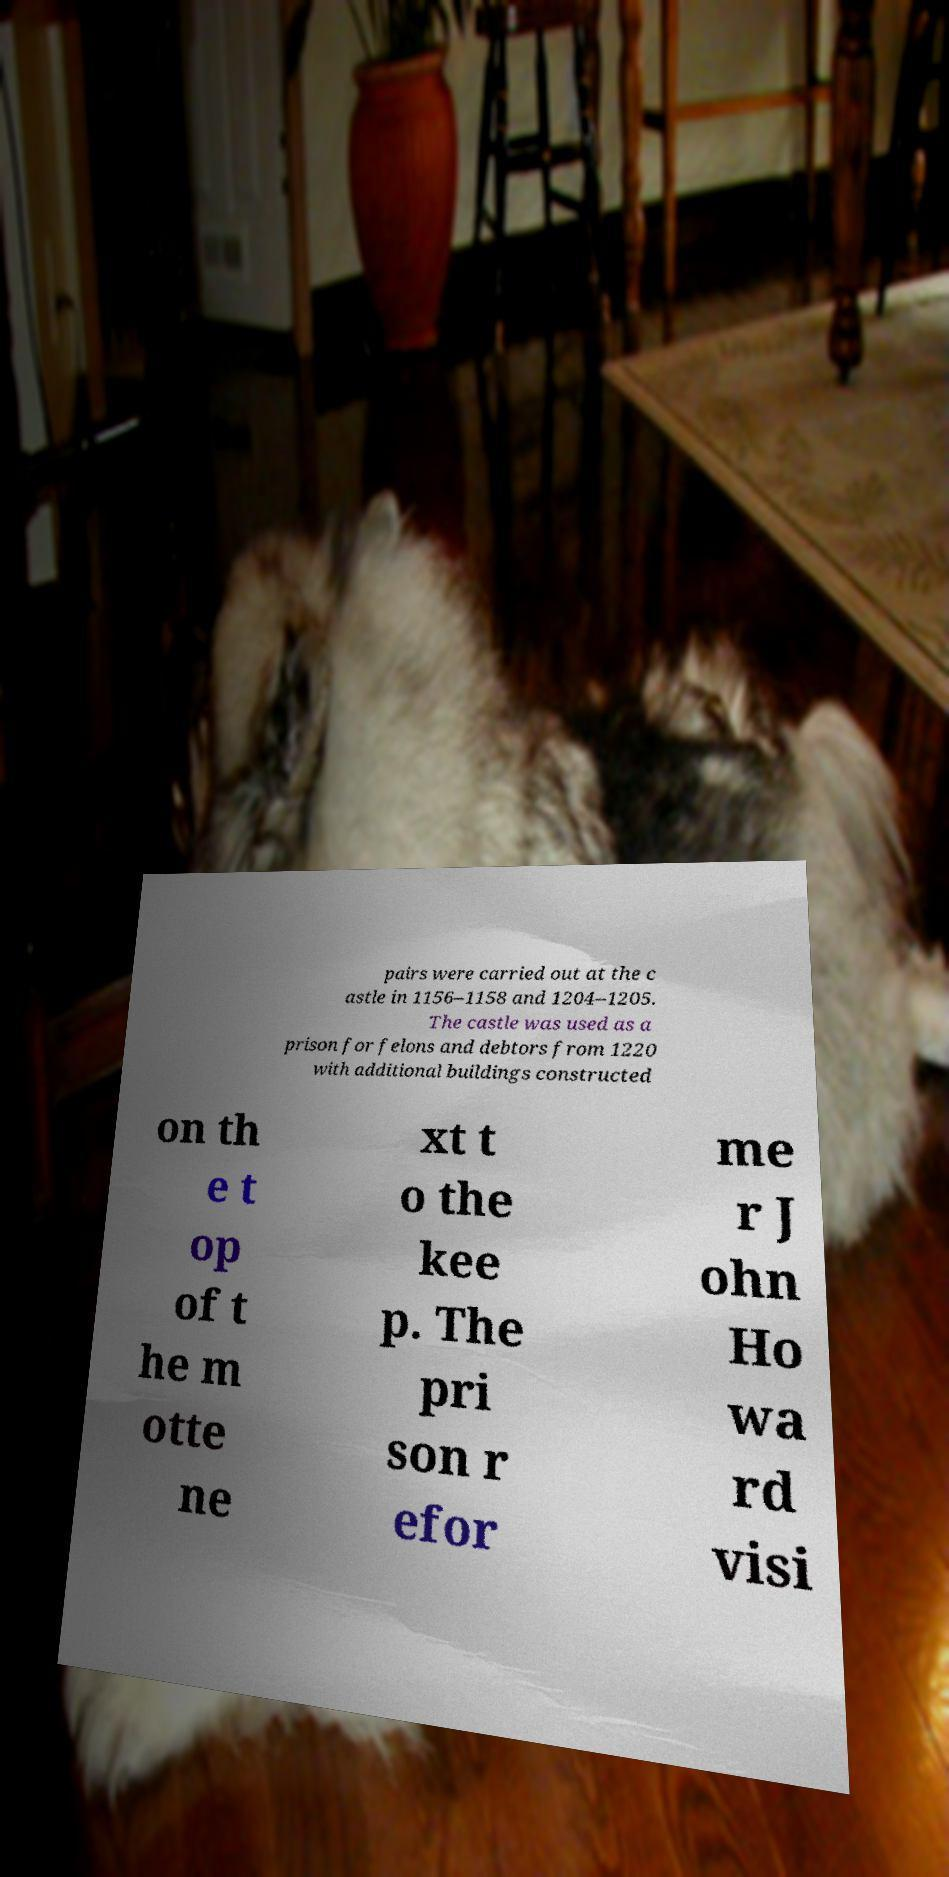For documentation purposes, I need the text within this image transcribed. Could you provide that? pairs were carried out at the c astle in 1156–1158 and 1204–1205. The castle was used as a prison for felons and debtors from 1220 with additional buildings constructed on th e t op of t he m otte ne xt t o the kee p. The pri son r efor me r J ohn Ho wa rd visi 